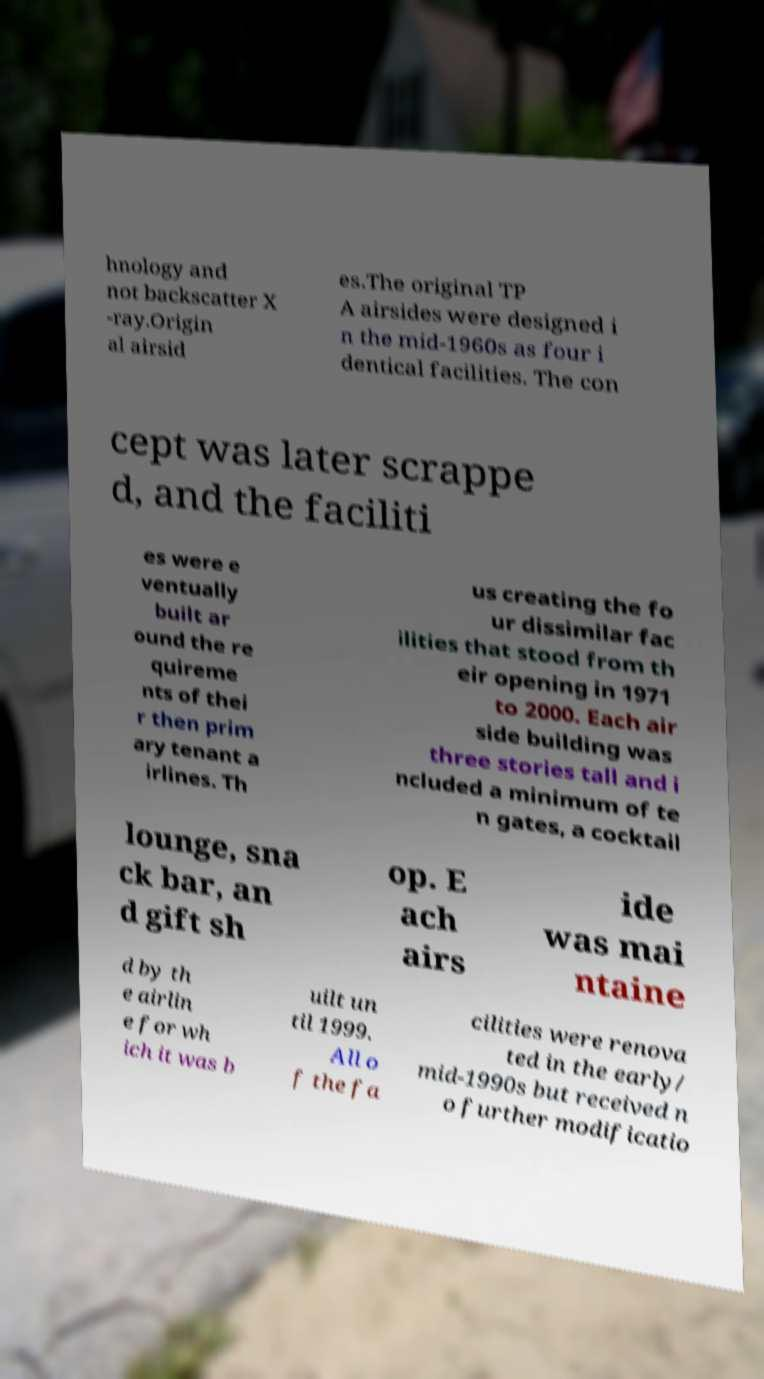There's text embedded in this image that I need extracted. Can you transcribe it verbatim? hnology and not backscatter X -ray.Origin al airsid es.The original TP A airsides were designed i n the mid-1960s as four i dentical facilities. The con cept was later scrappe d, and the faciliti es were e ventually built ar ound the re quireme nts of thei r then prim ary tenant a irlines. Th us creating the fo ur dissimilar fac ilities that stood from th eir opening in 1971 to 2000. Each air side building was three stories tall and i ncluded a minimum of te n gates, a cocktail lounge, sna ck bar, an d gift sh op. E ach airs ide was mai ntaine d by th e airlin e for wh ich it was b uilt un til 1999. All o f the fa cilities were renova ted in the early/ mid-1990s but received n o further modificatio 